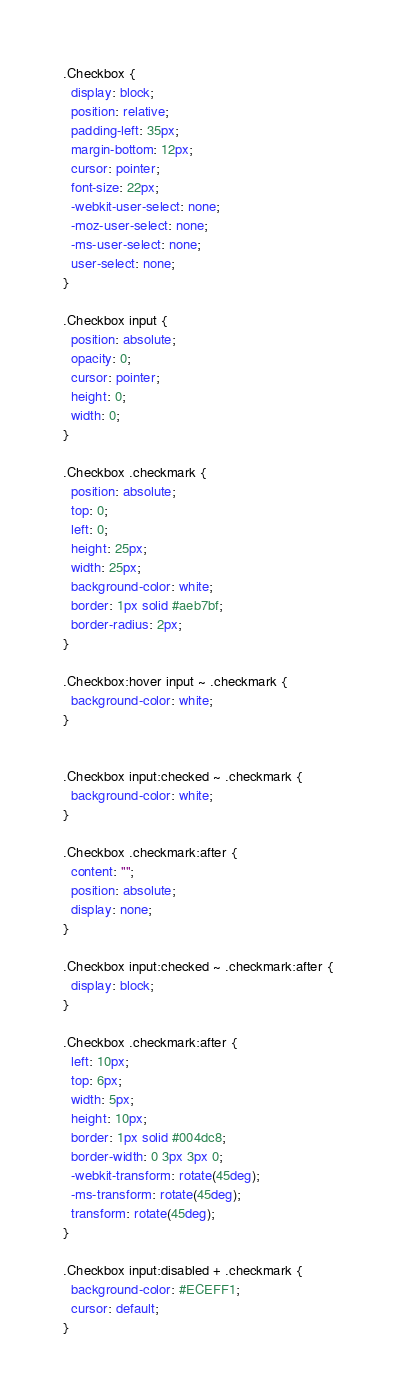<code> <loc_0><loc_0><loc_500><loc_500><_CSS_>.Checkbox {
  display: block;
  position: relative;
  padding-left: 35px;
  margin-bottom: 12px;
  cursor: pointer;
  font-size: 22px;
  -webkit-user-select: none;
  -moz-user-select: none;
  -ms-user-select: none;
  user-select: none;
}

.Checkbox input {
  position: absolute;
  opacity: 0;
  cursor: pointer;
  height: 0;
  width: 0;
}

.Checkbox .checkmark {
  position: absolute;
  top: 0;
  left: 0;
  height: 25px;
  width: 25px;
  background-color: white;
  border: 1px solid #aeb7bf;
  border-radius: 2px;
}

.Checkbox:hover input ~ .checkmark {
  background-color: white;
}


.Checkbox input:checked ~ .checkmark {
  background-color: white;
}

.Checkbox .checkmark:after {
  content: "";
  position: absolute;
  display: none;
}

.Checkbox input:checked ~ .checkmark:after {
  display: block;
}

.Checkbox .checkmark:after {
  left: 10px;
  top: 6px;
  width: 5px;
  height: 10px;
  border: 1px solid #004dc8;
  border-width: 0 3px 3px 0;
  -webkit-transform: rotate(45deg);
  -ms-transform: rotate(45deg);
  transform: rotate(45deg);
}

.Checkbox input:disabled + .checkmark {
  background-color: #ECEFF1;
  cursor: default;
}</code> 